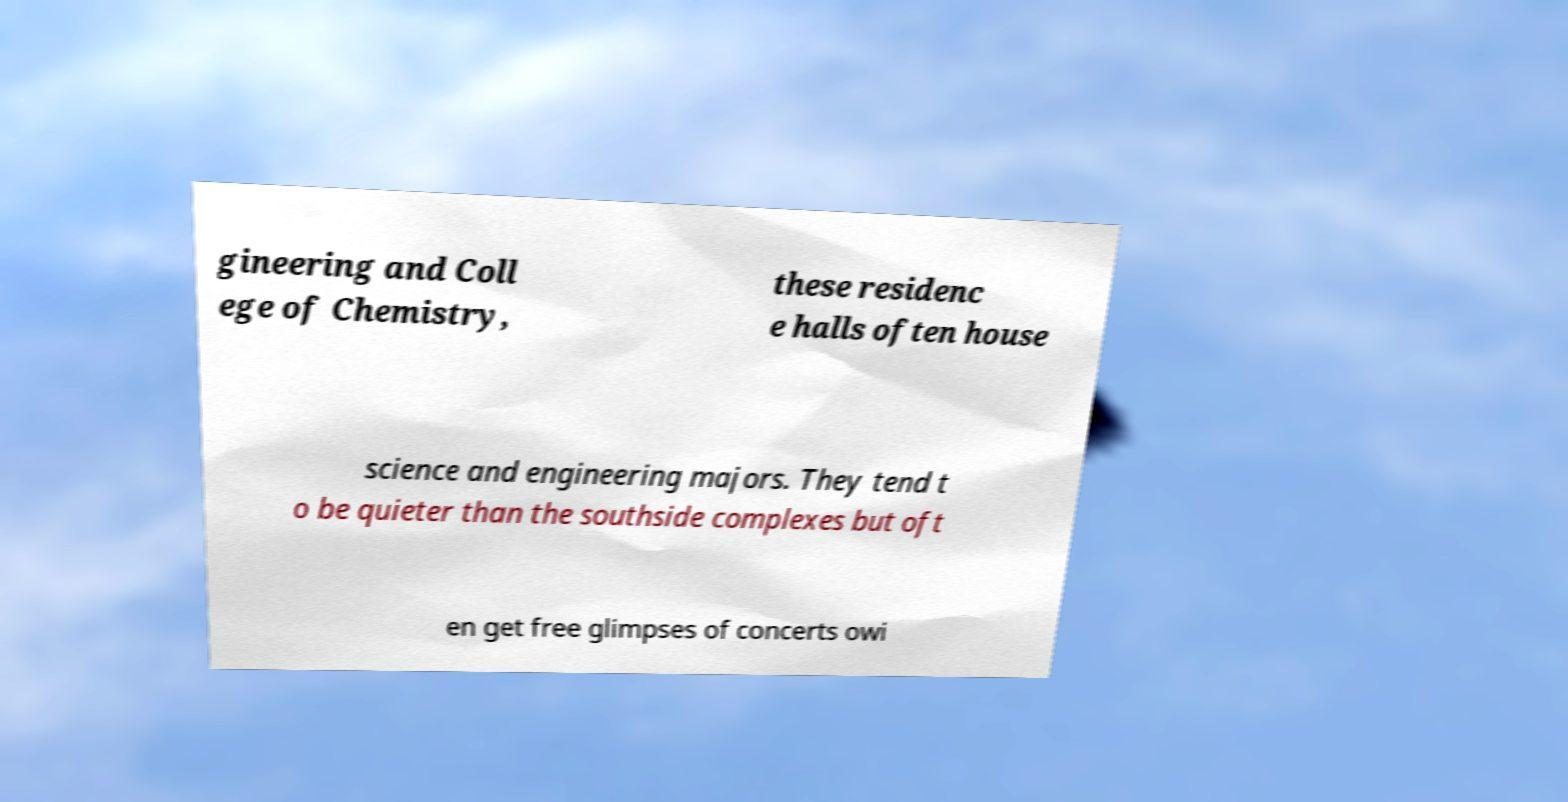I need the written content from this picture converted into text. Can you do that? gineering and Coll ege of Chemistry, these residenc e halls often house science and engineering majors. They tend t o be quieter than the southside complexes but oft en get free glimpses of concerts owi 